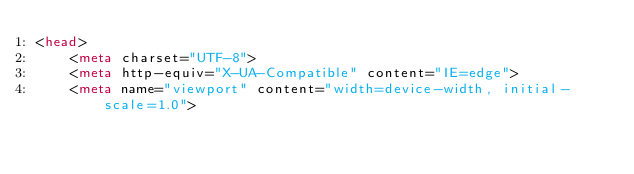<code> <loc_0><loc_0><loc_500><loc_500><_HTML_><head>
    <meta charset="UTF-8">
    <meta http-equiv="X-UA-Compatible" content="IE=edge">
    <meta name="viewport" content="width=device-width, initial-scale=1.0"></code> 